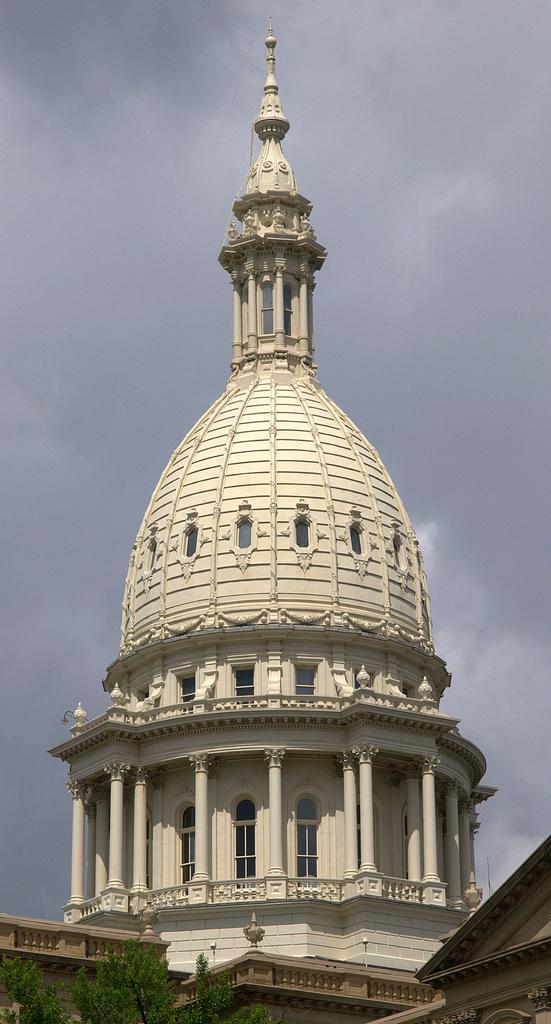What type of structure is present in the image? The image contains a building. How many buildings can be seen in the image? There are multiple buildings in the image. What type of vegetation is present in the image? There is a tree in the image. What is visible at the top of the image? Clouds are visible at the top of the image. Can you see an owl perched on the tree in the image? There is no owl present in the image; only the tree and buildings are visible. Is there a yard with a fence surrounding the buildings in the image? There is no yard or fence visible in the image; only the buildings and tree are present. 